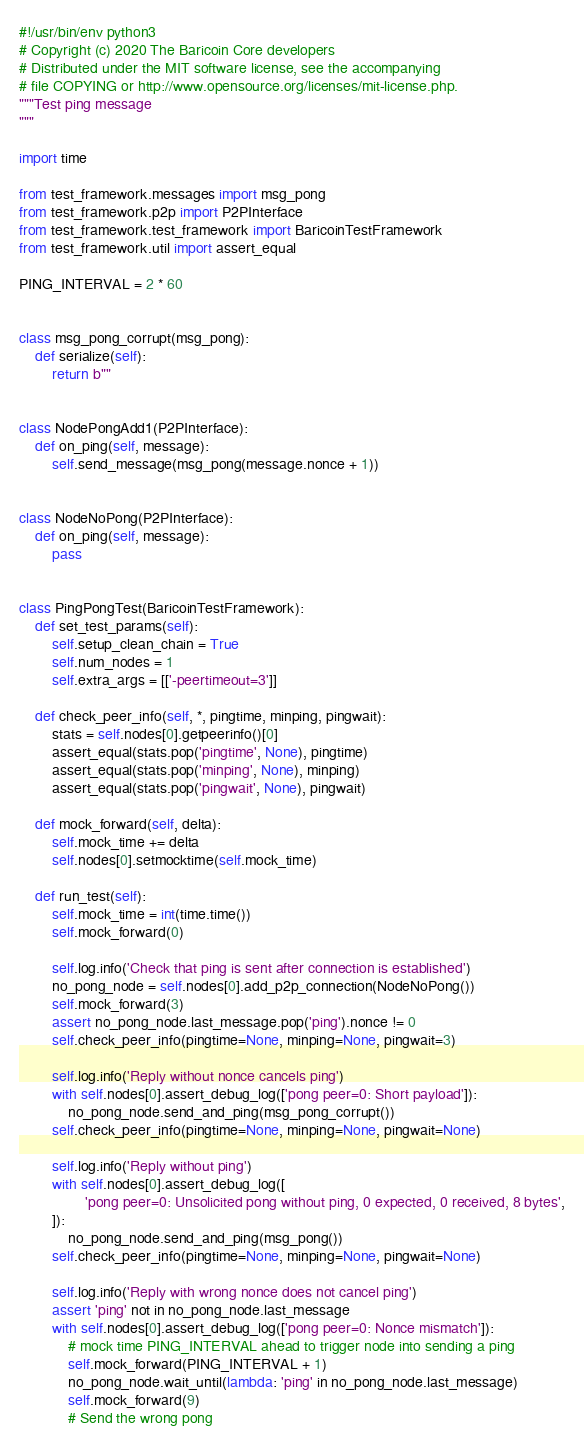Convert code to text. <code><loc_0><loc_0><loc_500><loc_500><_Python_>#!/usr/bin/env python3
# Copyright (c) 2020 The Baricoin Core developers
# Distributed under the MIT software license, see the accompanying
# file COPYING or http://www.opensource.org/licenses/mit-license.php.
"""Test ping message
"""

import time

from test_framework.messages import msg_pong
from test_framework.p2p import P2PInterface
from test_framework.test_framework import BaricoinTestFramework
from test_framework.util import assert_equal

PING_INTERVAL = 2 * 60


class msg_pong_corrupt(msg_pong):
    def serialize(self):
        return b""


class NodePongAdd1(P2PInterface):
    def on_ping(self, message):
        self.send_message(msg_pong(message.nonce + 1))


class NodeNoPong(P2PInterface):
    def on_ping(self, message):
        pass


class PingPongTest(BaricoinTestFramework):
    def set_test_params(self):
        self.setup_clean_chain = True
        self.num_nodes = 1
        self.extra_args = [['-peertimeout=3']]

    def check_peer_info(self, *, pingtime, minping, pingwait):
        stats = self.nodes[0].getpeerinfo()[0]
        assert_equal(stats.pop('pingtime', None), pingtime)
        assert_equal(stats.pop('minping', None), minping)
        assert_equal(stats.pop('pingwait', None), pingwait)

    def mock_forward(self, delta):
        self.mock_time += delta
        self.nodes[0].setmocktime(self.mock_time)

    def run_test(self):
        self.mock_time = int(time.time())
        self.mock_forward(0)

        self.log.info('Check that ping is sent after connection is established')
        no_pong_node = self.nodes[0].add_p2p_connection(NodeNoPong())
        self.mock_forward(3)
        assert no_pong_node.last_message.pop('ping').nonce != 0
        self.check_peer_info(pingtime=None, minping=None, pingwait=3)

        self.log.info('Reply without nonce cancels ping')
        with self.nodes[0].assert_debug_log(['pong peer=0: Short payload']):
            no_pong_node.send_and_ping(msg_pong_corrupt())
        self.check_peer_info(pingtime=None, minping=None, pingwait=None)

        self.log.info('Reply without ping')
        with self.nodes[0].assert_debug_log([
                'pong peer=0: Unsolicited pong without ping, 0 expected, 0 received, 8 bytes',
        ]):
            no_pong_node.send_and_ping(msg_pong())
        self.check_peer_info(pingtime=None, minping=None, pingwait=None)

        self.log.info('Reply with wrong nonce does not cancel ping')
        assert 'ping' not in no_pong_node.last_message
        with self.nodes[0].assert_debug_log(['pong peer=0: Nonce mismatch']):
            # mock time PING_INTERVAL ahead to trigger node into sending a ping
            self.mock_forward(PING_INTERVAL + 1)
            no_pong_node.wait_until(lambda: 'ping' in no_pong_node.last_message)
            self.mock_forward(9)
            # Send the wrong pong</code> 